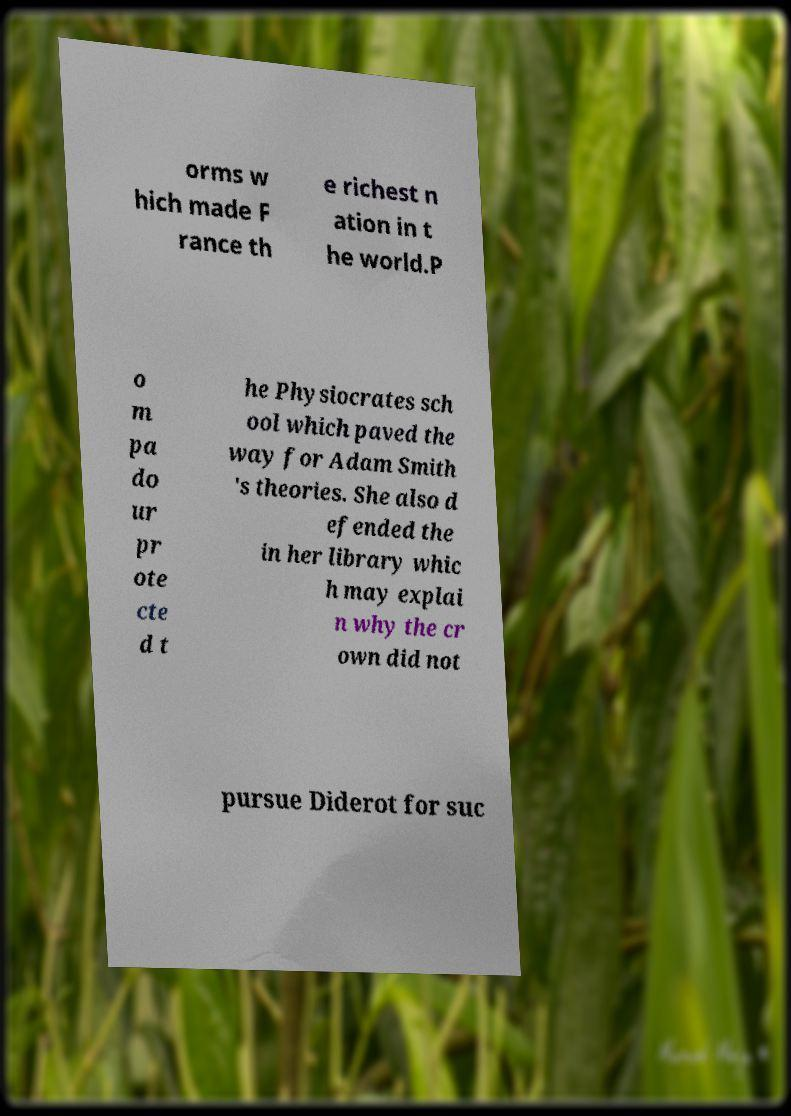Please identify and transcribe the text found in this image. orms w hich made F rance th e richest n ation in t he world.P o m pa do ur pr ote cte d t he Physiocrates sch ool which paved the way for Adam Smith 's theories. She also d efended the in her library whic h may explai n why the cr own did not pursue Diderot for suc 